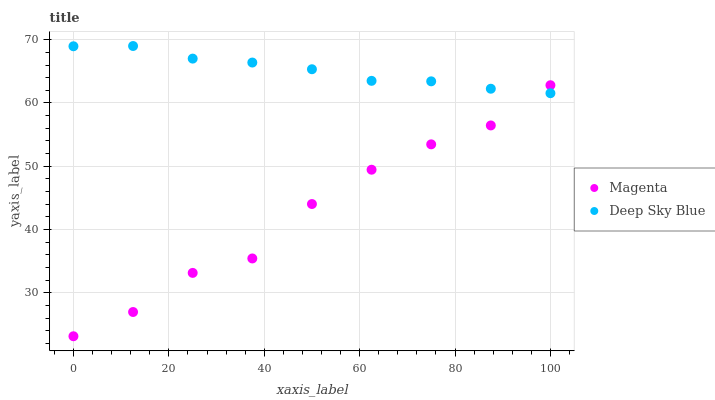Does Magenta have the minimum area under the curve?
Answer yes or no. Yes. Does Deep Sky Blue have the maximum area under the curve?
Answer yes or no. Yes. Does Deep Sky Blue have the minimum area under the curve?
Answer yes or no. No. Is Deep Sky Blue the smoothest?
Answer yes or no. Yes. Is Magenta the roughest?
Answer yes or no. Yes. Is Deep Sky Blue the roughest?
Answer yes or no. No. Does Magenta have the lowest value?
Answer yes or no. Yes. Does Deep Sky Blue have the lowest value?
Answer yes or no. No. Does Deep Sky Blue have the highest value?
Answer yes or no. Yes. Does Deep Sky Blue intersect Magenta?
Answer yes or no. Yes. Is Deep Sky Blue less than Magenta?
Answer yes or no. No. Is Deep Sky Blue greater than Magenta?
Answer yes or no. No. 